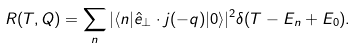Convert formula to latex. <formula><loc_0><loc_0><loc_500><loc_500>R ( T , Q ) = \sum _ { n } | \langle n | \hat { e } _ { \perp } \cdot { j } ( - { q } ) | 0 \rangle | ^ { 2 } \delta ( T - E _ { n } + E _ { 0 } ) .</formula> 